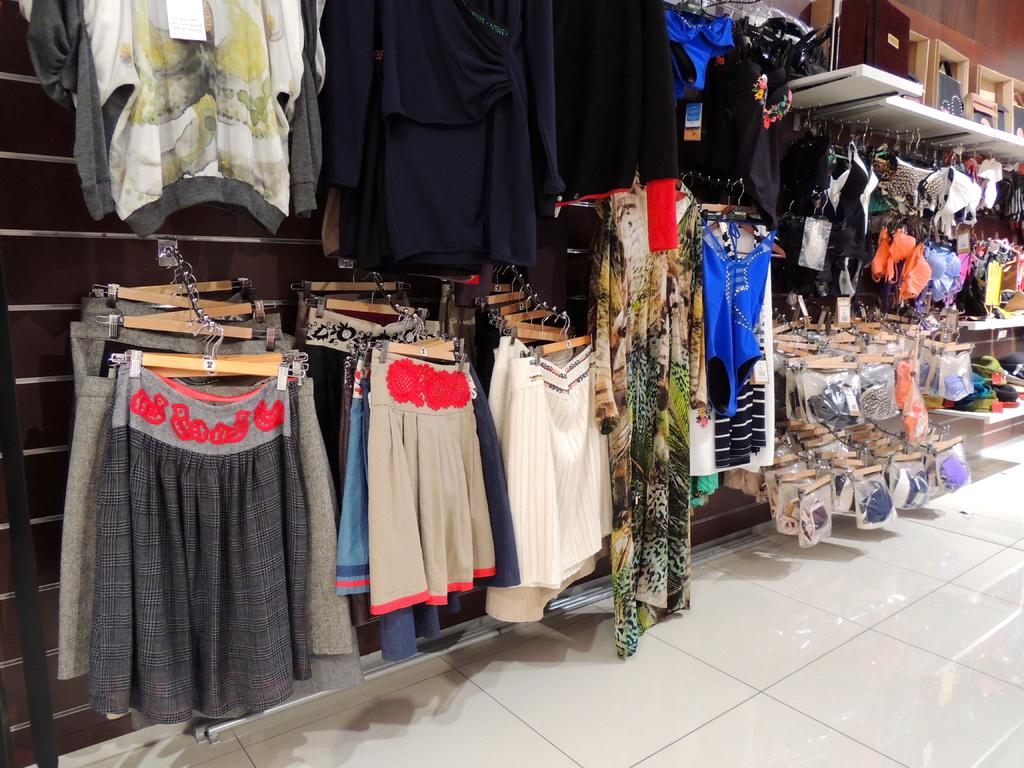What can be seen hanging on the clothes hangers in the image? There are clothes hanging on clothes hangers in the image. Can you describe any other items visible in the image? Unfortunately, the provided facts do not specify any other items visible in the image. What type of paint is being used to decorate the scarecrow in the image? There is no scarecrow or paint present in the image. 